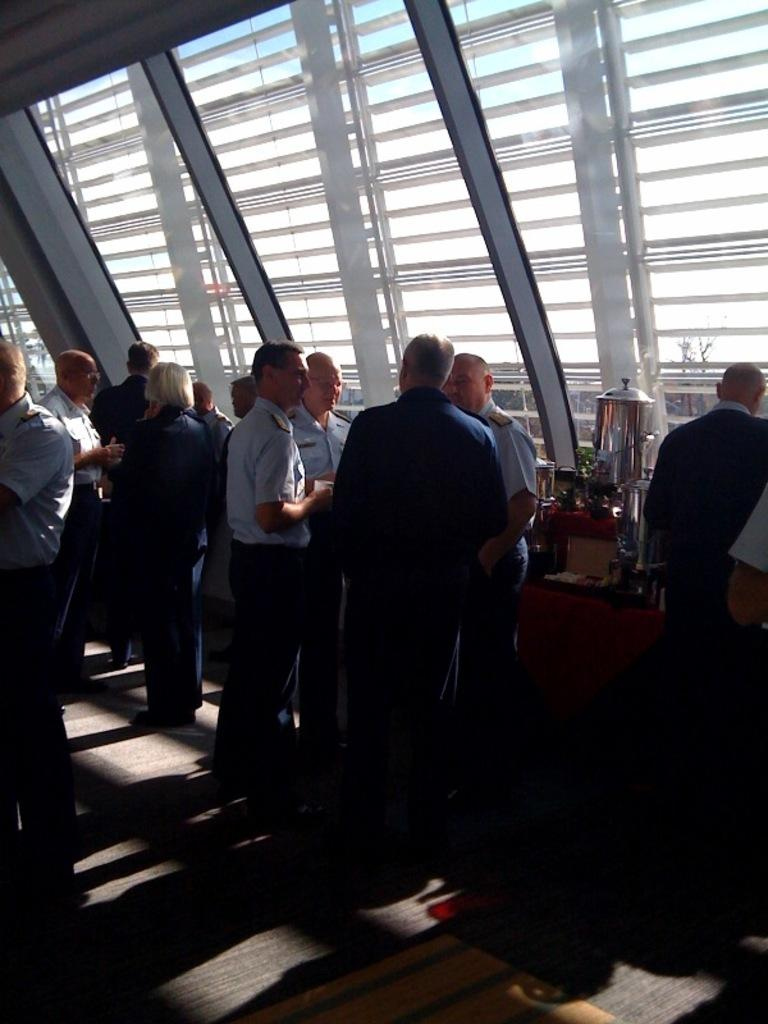What are the people in the image doing? The people in the image are standing. What are some of the people holding in their hands? Some people are holding objects in their hands. What is a prominent feature in the image? There is a table in the image. What can be found on the table? The table has objects on it. Reasoning: Let's think step by breaking down the conversation step by step. We start by describing the actions of the people in the image, which is standing. Then, we mention that some of them are holding objects in their hands. Next, we identify a prominent feature in the image, which is the table. Finally, we describe what can be found on the table, which is objects. Absurd Question/Answer: What type of rake is being used to create a line in the image? There is no rake or line present in the image. 